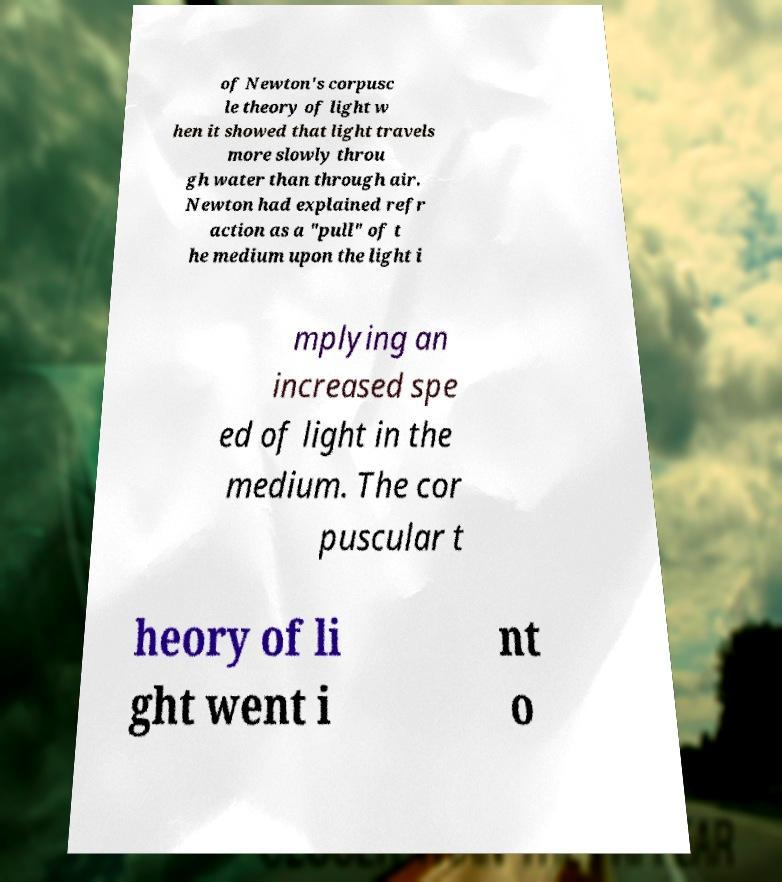I need the written content from this picture converted into text. Can you do that? of Newton's corpusc le theory of light w hen it showed that light travels more slowly throu gh water than through air. Newton had explained refr action as a "pull" of t he medium upon the light i mplying an increased spe ed of light in the medium. The cor puscular t heory of li ght went i nt o 